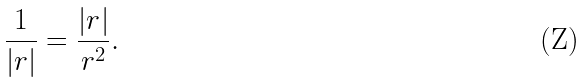Convert formula to latex. <formula><loc_0><loc_0><loc_500><loc_500>\frac { 1 } { | r | } = \frac { | r | } { r ^ { 2 } } .</formula> 